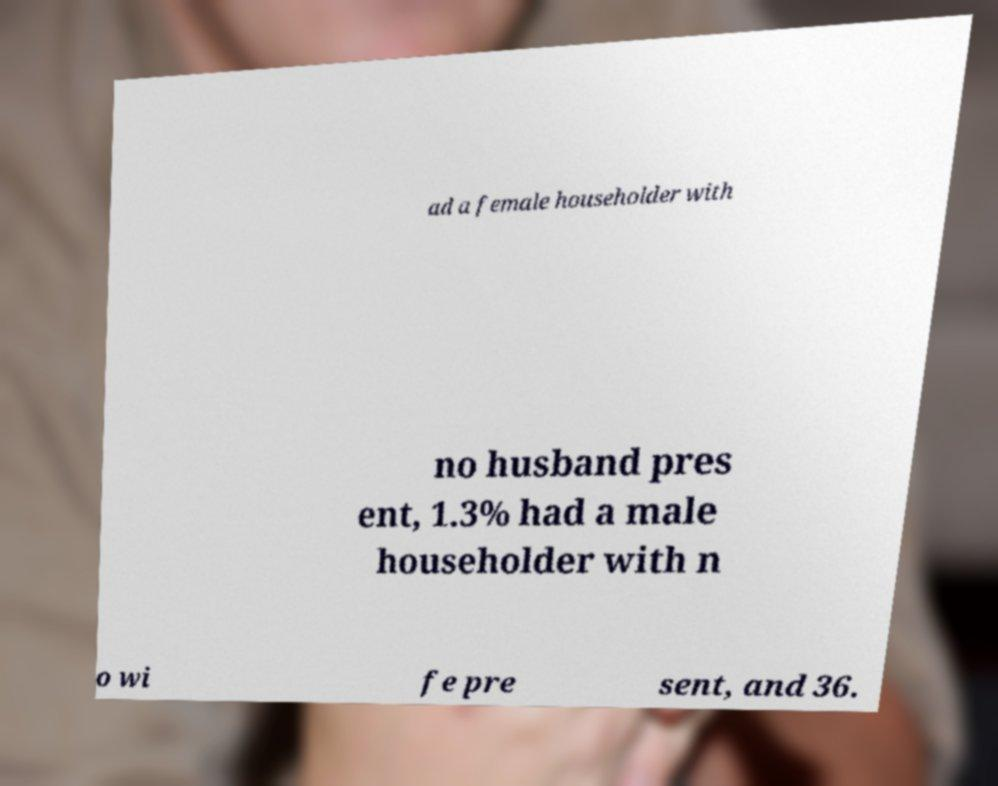There's text embedded in this image that I need extracted. Can you transcribe it verbatim? ad a female householder with no husband pres ent, 1.3% had a male householder with n o wi fe pre sent, and 36. 